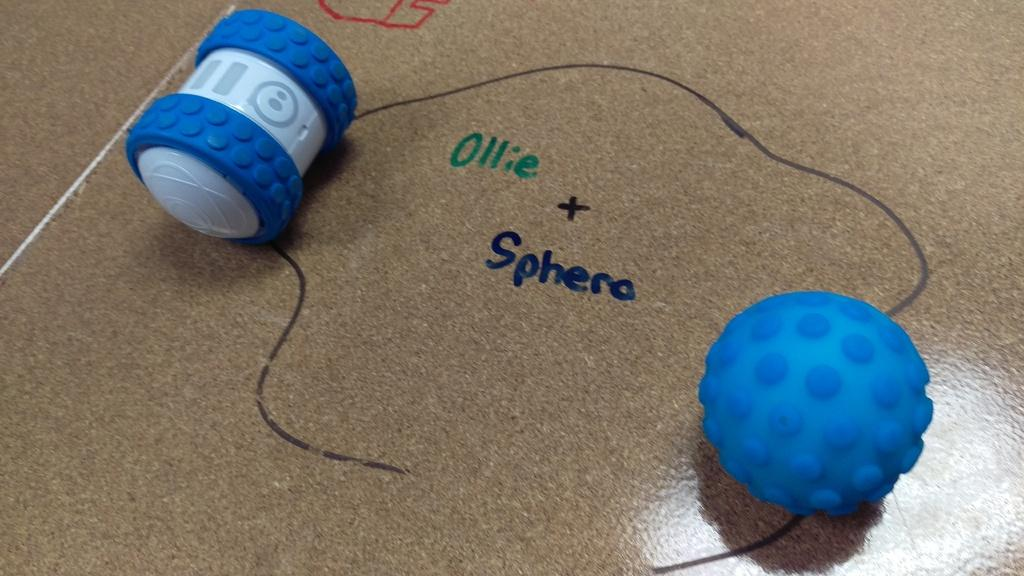<image>
Share a concise interpretation of the image provided. a desk with the words ollie plus sphera drawn on in marker. 